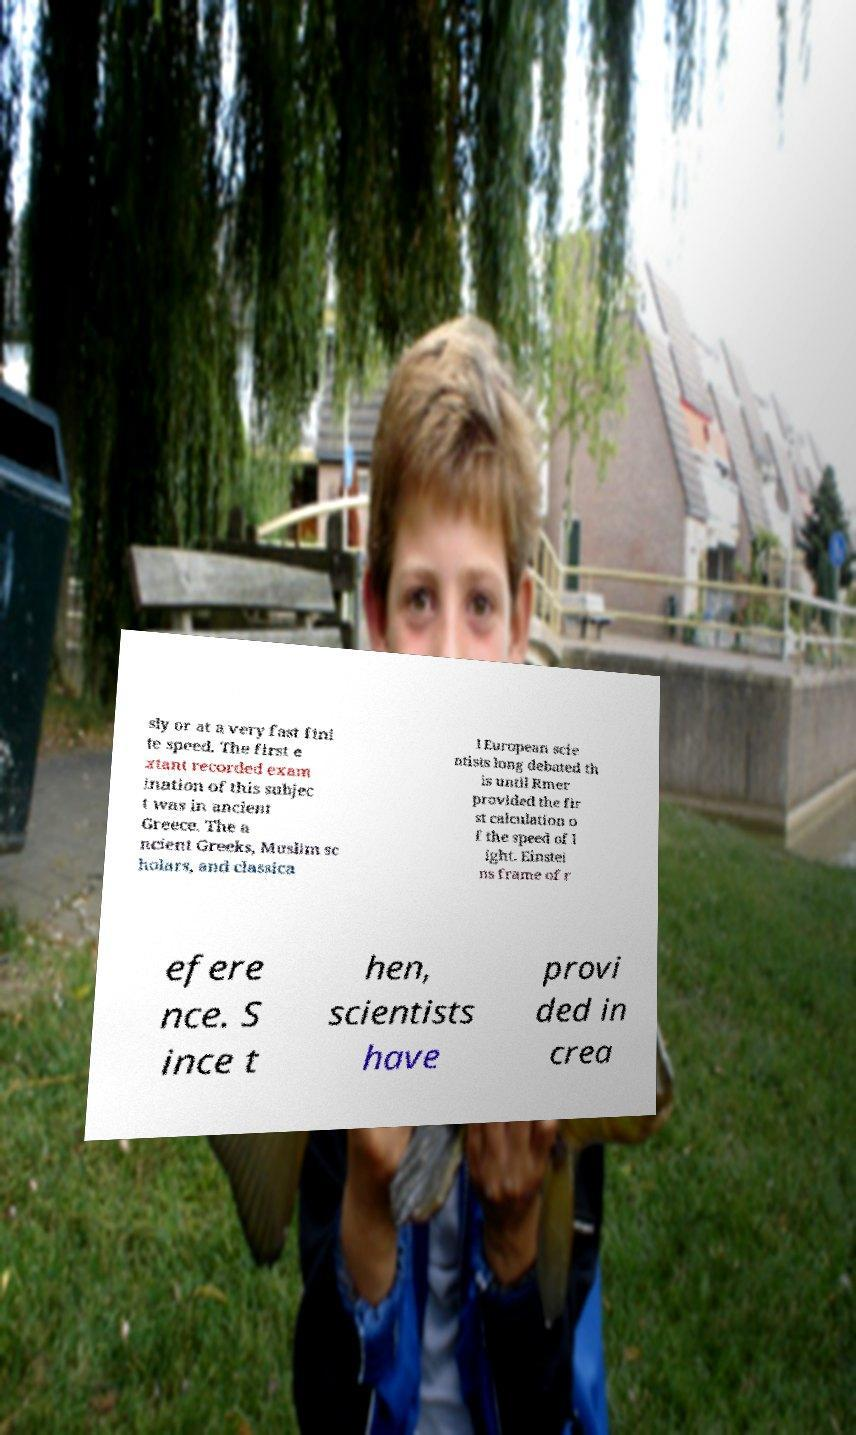Can you read and provide the text displayed in the image?This photo seems to have some interesting text. Can you extract and type it out for me? sly or at a very fast fini te speed. The first e xtant recorded exam ination of this subjec t was in ancient Greece. The a ncient Greeks, Muslim sc holars, and classica l European scie ntists long debated th is until Rmer provided the fir st calculation o f the speed of l ight. Einstei ns frame of r efere nce. S ince t hen, scientists have provi ded in crea 